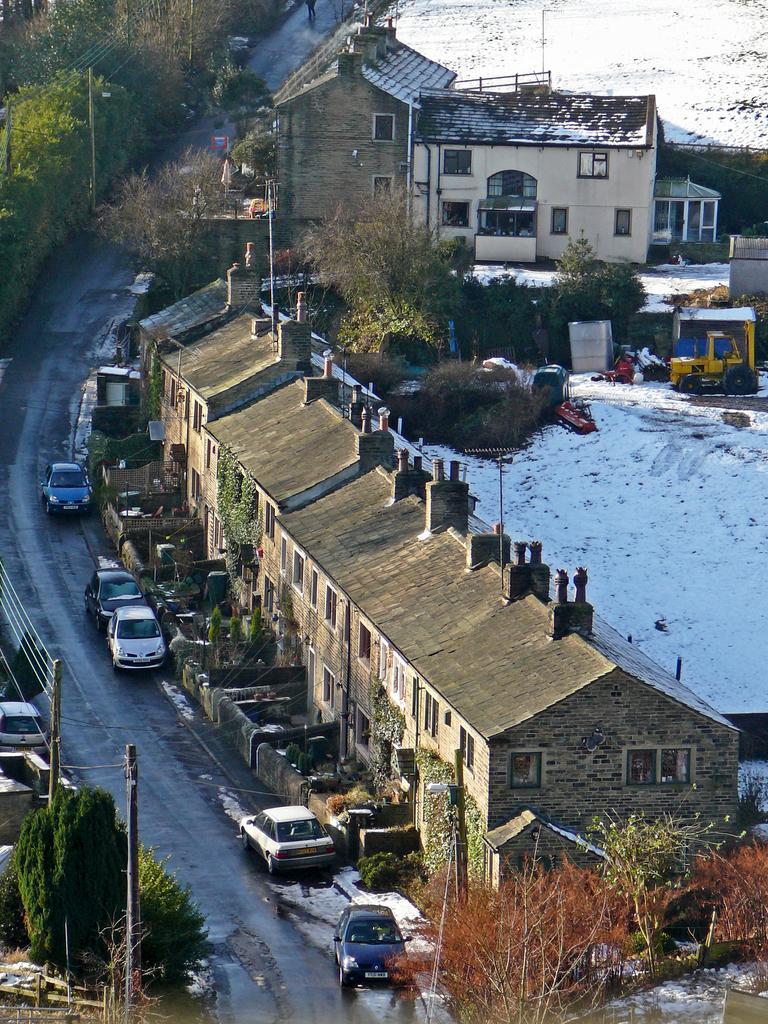Could you give a brief overview of what you see in this image? In this image I can see many vehicles on the road. To the right I can see many buildings and the snow. On both sides of the road I can see many trees and to the left I can see the poles. 